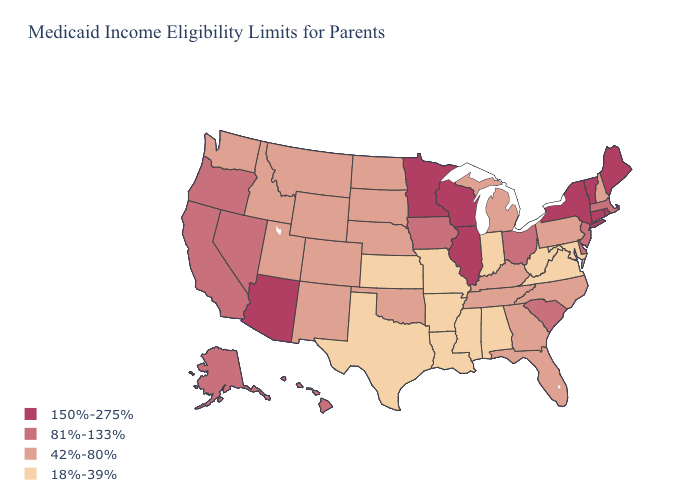Does the first symbol in the legend represent the smallest category?
Give a very brief answer. No. Among the states that border Minnesota , does Wisconsin have the highest value?
Keep it brief. Yes. Name the states that have a value in the range 150%-275%?
Quick response, please. Arizona, Connecticut, Illinois, Maine, Minnesota, New York, Rhode Island, Vermont, Wisconsin. Is the legend a continuous bar?
Concise answer only. No. Name the states that have a value in the range 18%-39%?
Answer briefly. Alabama, Arkansas, Indiana, Kansas, Louisiana, Maryland, Mississippi, Missouri, Texas, Virginia, West Virginia. What is the lowest value in the Northeast?
Concise answer only. 42%-80%. Name the states that have a value in the range 150%-275%?
Keep it brief. Arizona, Connecticut, Illinois, Maine, Minnesota, New York, Rhode Island, Vermont, Wisconsin. Name the states that have a value in the range 81%-133%?
Write a very short answer. Alaska, California, Delaware, Hawaii, Iowa, Massachusetts, Nevada, New Jersey, Ohio, Oregon, South Carolina. What is the lowest value in the Northeast?
Give a very brief answer. 42%-80%. Which states hav the highest value in the Northeast?
Concise answer only. Connecticut, Maine, New York, Rhode Island, Vermont. Does Alaska have the lowest value in the West?
Short answer required. No. Does Kentucky have the same value as Nevada?
Quick response, please. No. What is the value of Tennessee?
Answer briefly. 42%-80%. What is the highest value in the Northeast ?
Give a very brief answer. 150%-275%. 